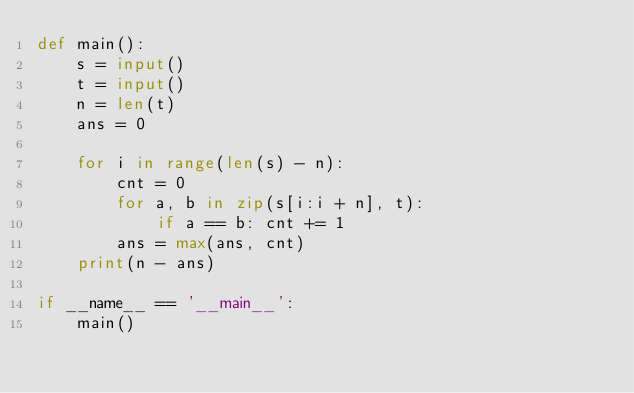<code> <loc_0><loc_0><loc_500><loc_500><_Python_>def main():
    s = input()
    t = input()
    n = len(t)
    ans = 0

    for i in range(len(s) - n):
        cnt = 0
        for a, b in zip(s[i:i + n], t):
            if a == b: cnt += 1
        ans = max(ans, cnt)
    print(n - ans)

if __name__ == '__main__':
    main()

</code> 